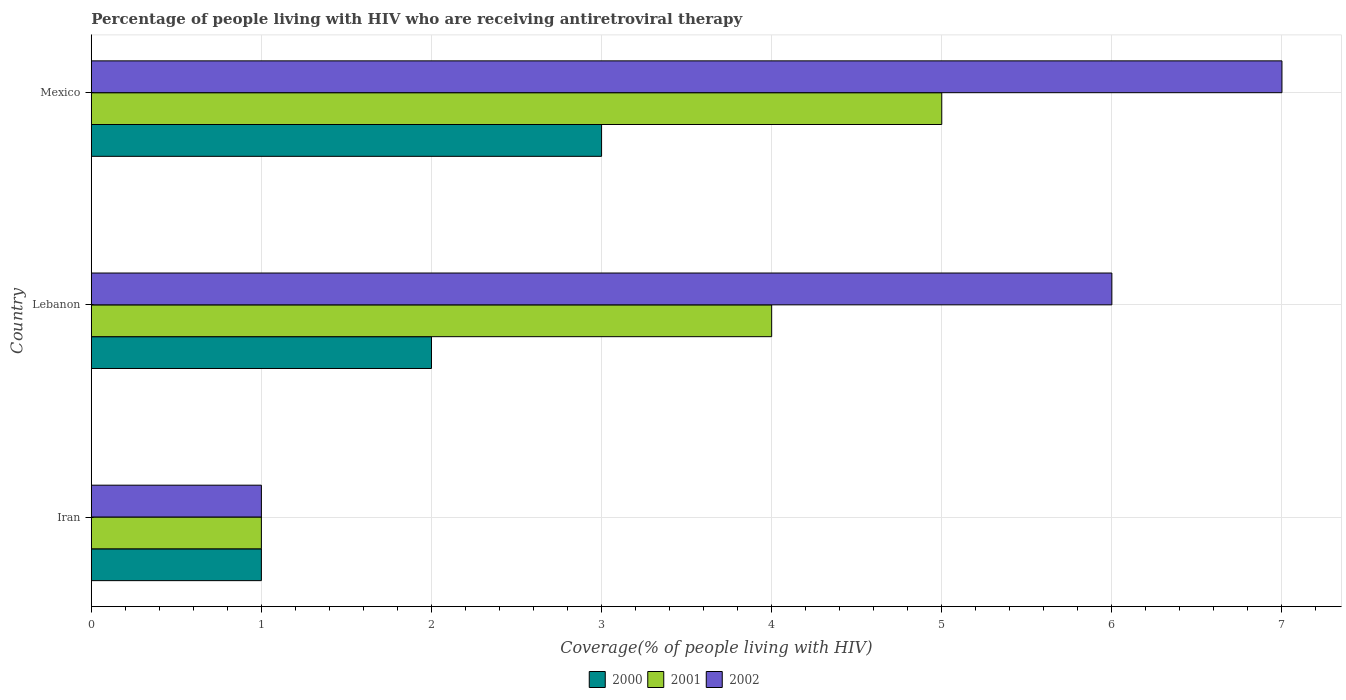How many groups of bars are there?
Make the answer very short. 3. How many bars are there on the 3rd tick from the bottom?
Provide a short and direct response. 3. What is the label of the 3rd group of bars from the top?
Your answer should be very brief. Iran. Across all countries, what is the maximum percentage of the HIV infected people who are receiving antiretroviral therapy in 2001?
Offer a very short reply. 5. Across all countries, what is the minimum percentage of the HIV infected people who are receiving antiretroviral therapy in 2002?
Give a very brief answer. 1. In which country was the percentage of the HIV infected people who are receiving antiretroviral therapy in 2000 minimum?
Your answer should be compact. Iran. What is the total percentage of the HIV infected people who are receiving antiretroviral therapy in 2001 in the graph?
Your answer should be very brief. 10. What is the difference between the percentage of the HIV infected people who are receiving antiretroviral therapy in 2002 in Iran and that in Mexico?
Your response must be concise. -6. What is the average percentage of the HIV infected people who are receiving antiretroviral therapy in 2002 per country?
Offer a terse response. 4.67. What is the difference between the percentage of the HIV infected people who are receiving antiretroviral therapy in 2001 and percentage of the HIV infected people who are receiving antiretroviral therapy in 2000 in Lebanon?
Your answer should be very brief. 2. What is the ratio of the percentage of the HIV infected people who are receiving antiretroviral therapy in 2000 in Iran to that in Lebanon?
Ensure brevity in your answer.  0.5. Is the percentage of the HIV infected people who are receiving antiretroviral therapy in 2002 in Iran less than that in Lebanon?
Your answer should be compact. Yes. Is the difference between the percentage of the HIV infected people who are receiving antiretroviral therapy in 2001 in Lebanon and Mexico greater than the difference between the percentage of the HIV infected people who are receiving antiretroviral therapy in 2000 in Lebanon and Mexico?
Provide a short and direct response. No. What is the difference between the highest and the second highest percentage of the HIV infected people who are receiving antiretroviral therapy in 2000?
Offer a very short reply. 1. What does the 1st bar from the bottom in Mexico represents?
Your response must be concise. 2000. Does the graph contain any zero values?
Ensure brevity in your answer.  No. Where does the legend appear in the graph?
Your answer should be very brief. Bottom center. What is the title of the graph?
Give a very brief answer. Percentage of people living with HIV who are receiving antiretroviral therapy. What is the label or title of the X-axis?
Provide a short and direct response. Coverage(% of people living with HIV). What is the Coverage(% of people living with HIV) in 2001 in Iran?
Your answer should be very brief. 1. What is the Coverage(% of people living with HIV) in 2000 in Lebanon?
Your answer should be compact. 2. What is the Coverage(% of people living with HIV) in 2002 in Lebanon?
Your answer should be very brief. 6. What is the Coverage(% of people living with HIV) of 2002 in Mexico?
Your response must be concise. 7. Across all countries, what is the maximum Coverage(% of people living with HIV) in 2000?
Your answer should be compact. 3. Across all countries, what is the minimum Coverage(% of people living with HIV) of 2000?
Offer a terse response. 1. Across all countries, what is the minimum Coverage(% of people living with HIV) of 2001?
Your answer should be very brief. 1. Across all countries, what is the minimum Coverage(% of people living with HIV) in 2002?
Your answer should be compact. 1. What is the total Coverage(% of people living with HIV) in 2001 in the graph?
Your answer should be compact. 10. What is the total Coverage(% of people living with HIV) of 2002 in the graph?
Offer a terse response. 14. What is the difference between the Coverage(% of people living with HIV) of 2000 in Iran and that in Lebanon?
Offer a terse response. -1. What is the difference between the Coverage(% of people living with HIV) of 2001 in Iran and that in Lebanon?
Make the answer very short. -3. What is the difference between the Coverage(% of people living with HIV) of 2002 in Iran and that in Lebanon?
Keep it short and to the point. -5. What is the difference between the Coverage(% of people living with HIV) in 2000 in Iran and that in Mexico?
Provide a short and direct response. -2. What is the difference between the Coverage(% of people living with HIV) in 2002 in Iran and that in Mexico?
Give a very brief answer. -6. What is the difference between the Coverage(% of people living with HIV) of 2000 in Lebanon and that in Mexico?
Provide a short and direct response. -1. What is the difference between the Coverage(% of people living with HIV) of 2002 in Lebanon and that in Mexico?
Ensure brevity in your answer.  -1. What is the difference between the Coverage(% of people living with HIV) of 2000 in Iran and the Coverage(% of people living with HIV) of 2001 in Lebanon?
Your answer should be very brief. -3. What is the difference between the Coverage(% of people living with HIV) of 2000 in Iran and the Coverage(% of people living with HIV) of 2002 in Lebanon?
Make the answer very short. -5. What is the difference between the Coverage(% of people living with HIV) of 2000 in Iran and the Coverage(% of people living with HIV) of 2001 in Mexico?
Your response must be concise. -4. What is the difference between the Coverage(% of people living with HIV) in 2000 in Iran and the Coverage(% of people living with HIV) in 2002 in Mexico?
Your answer should be very brief. -6. What is the difference between the Coverage(% of people living with HIV) in 2001 in Iran and the Coverage(% of people living with HIV) in 2002 in Mexico?
Provide a short and direct response. -6. What is the difference between the Coverage(% of people living with HIV) of 2001 in Lebanon and the Coverage(% of people living with HIV) of 2002 in Mexico?
Offer a very short reply. -3. What is the average Coverage(% of people living with HIV) in 2002 per country?
Provide a short and direct response. 4.67. What is the difference between the Coverage(% of people living with HIV) in 2000 and Coverage(% of people living with HIV) in 2001 in Iran?
Your answer should be compact. 0. What is the difference between the Coverage(% of people living with HIV) of 2001 and Coverage(% of people living with HIV) of 2002 in Iran?
Keep it short and to the point. 0. What is the difference between the Coverage(% of people living with HIV) of 2000 and Coverage(% of people living with HIV) of 2002 in Lebanon?
Provide a short and direct response. -4. What is the difference between the Coverage(% of people living with HIV) in 2000 and Coverage(% of people living with HIV) in 2002 in Mexico?
Your answer should be very brief. -4. What is the ratio of the Coverage(% of people living with HIV) in 2000 in Iran to that in Mexico?
Your answer should be very brief. 0.33. What is the ratio of the Coverage(% of people living with HIV) of 2002 in Iran to that in Mexico?
Your response must be concise. 0.14. What is the ratio of the Coverage(% of people living with HIV) of 2001 in Lebanon to that in Mexico?
Ensure brevity in your answer.  0.8. What is the difference between the highest and the second highest Coverage(% of people living with HIV) of 2000?
Your answer should be compact. 1. What is the difference between the highest and the second highest Coverage(% of people living with HIV) of 2001?
Provide a short and direct response. 1. What is the difference between the highest and the second highest Coverage(% of people living with HIV) of 2002?
Your response must be concise. 1. What is the difference between the highest and the lowest Coverage(% of people living with HIV) of 2001?
Make the answer very short. 4. 